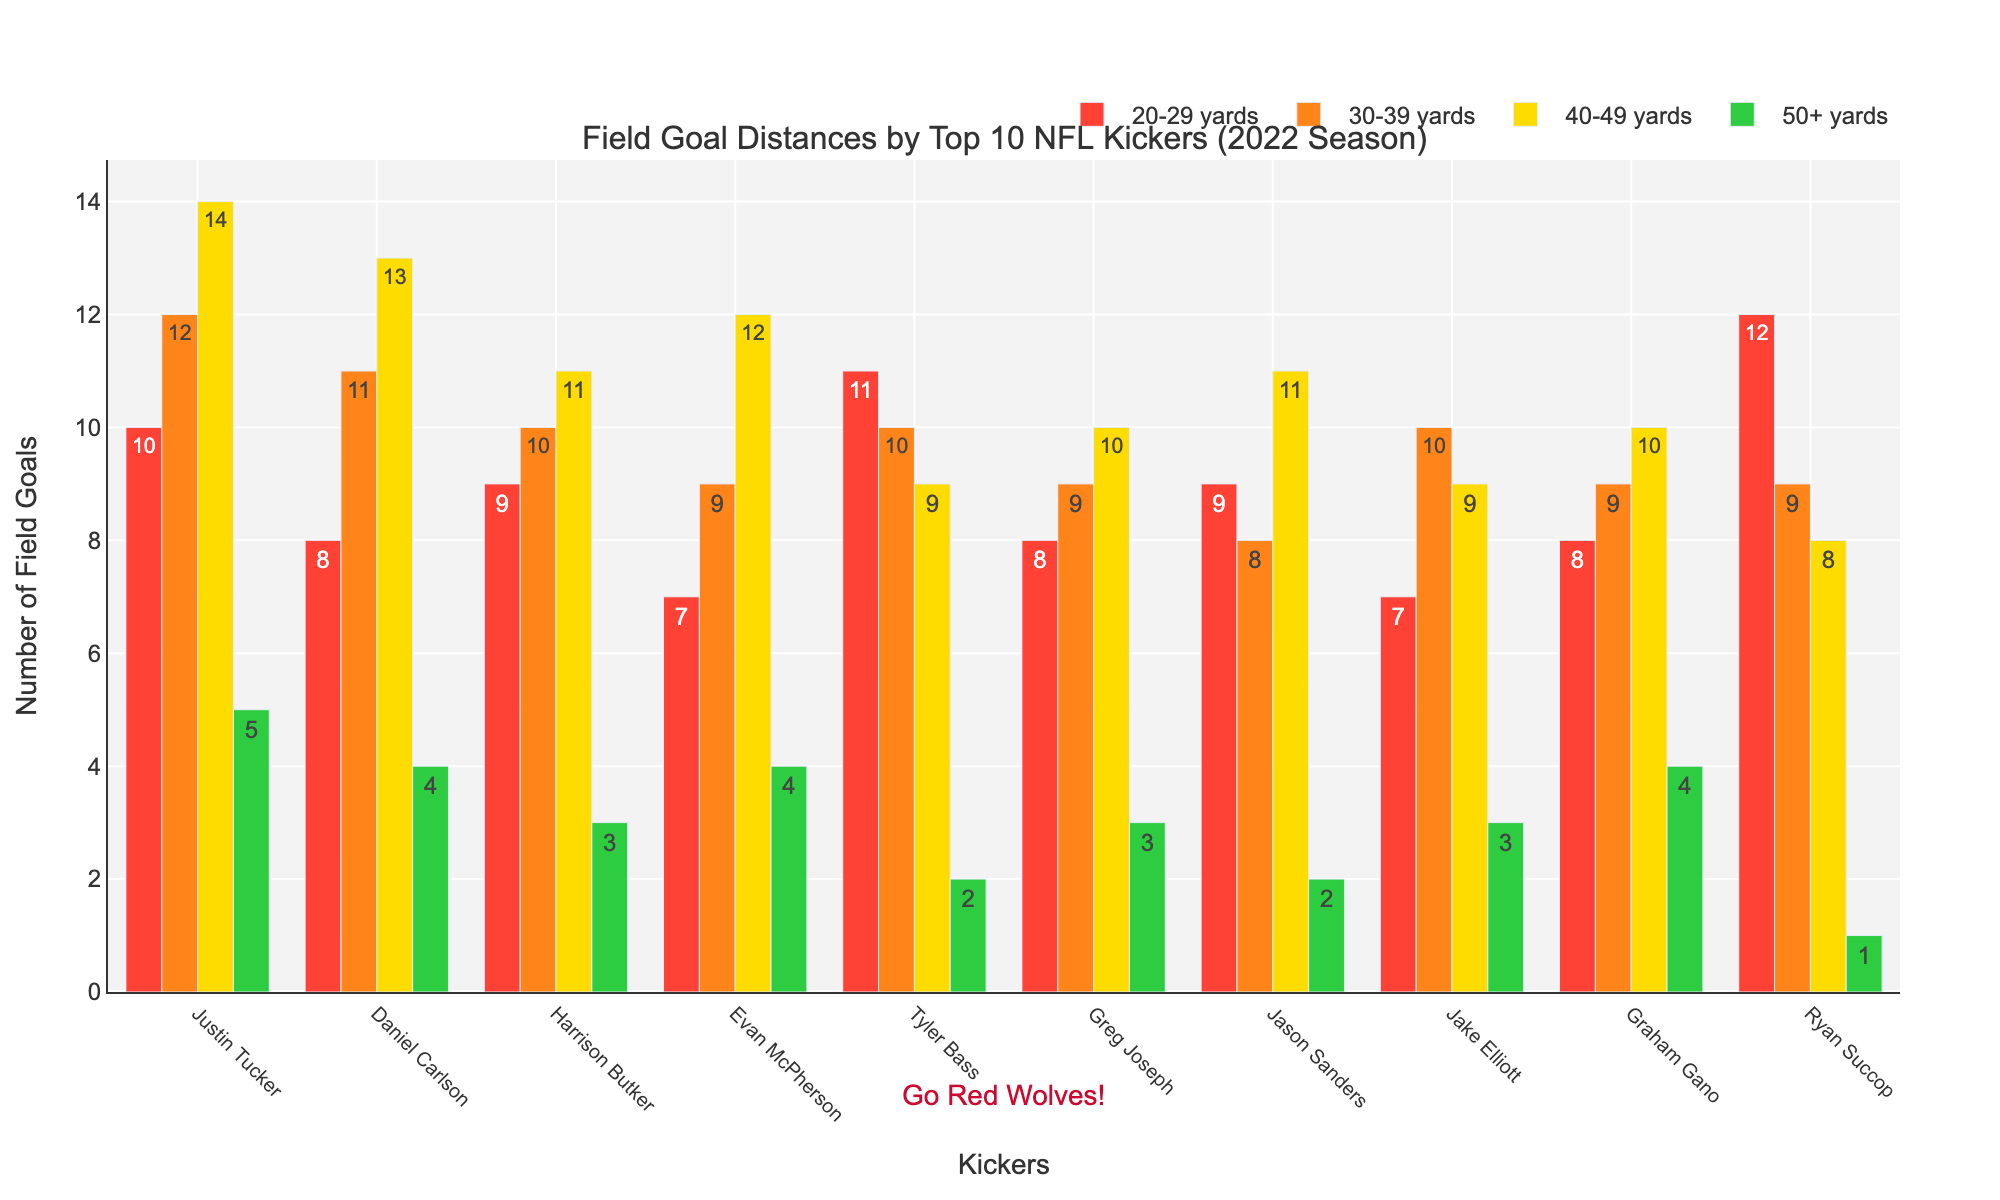Which kicker made the most field goals from the 20-29 yards range? Justin Tucker has the highest bar in the 20-29 yard range, with a value of 12.
Answer: Ryan Succop What is the total number of field goals made by Daniel Carlson from all ranges? Add the numbers for Daniel Carlson across all distance ranges: 8 + 11 + 13 + 4 = 36.
Answer: 36 Among the top 10 kickers, who has the least number of field goals made from the 50+ yards range? Ryan Succop has the smallest bar in the 50+ yard range, with a value of 1.
Answer: Ryan Succop How many more 50+ yard field goals did Justin Tucker make compared to Tyler Bass? Justin Tucker made 5, and Tyler Bass made 2. So, 5 - 2 = 3.
Answer: 3 Which two kickers made the same number of field goals from the 40-49 yards range? Graham Gano and Greg Joseph both made 10 field goals in this range, as indicated by their bars’ heights.
Answer: Graham Gano and Greg Joseph What is the average number of field goals made from the 30-39 yards range among these kickers? Add the numbers for all kickers from the 30-39 range and divide by 10: (12 + 11 + 10 + 9 + 10 + 9 + 8 + 10 + 9 + 9) / 10 = 9.7.
Answer: 9.7 Who made more field goals from the 40-49 yards range: Evan McPherson or Harrison Butker? The bar for Evan McPherson in the 40-49 yard range shows 12, while Harrison Butker shows 11.
Answer: Evan McPherson Which kicker has the most evenly distributed number of field goals across all ranges? By visually comparing the heights of the bars for each kicker, Harrison Butker shows relatively balanced heights across all ranges (9, 10, 11, 3).
Answer: Harrison Butker Comparing the number of field goals made from the 20-29 yard range, which kicker ranks second? Visually, Ryan Succop has the second-highest bar after Justin Tucker in the 20-29 yards range, with a value of 12.
Answer: Justin Tucker 